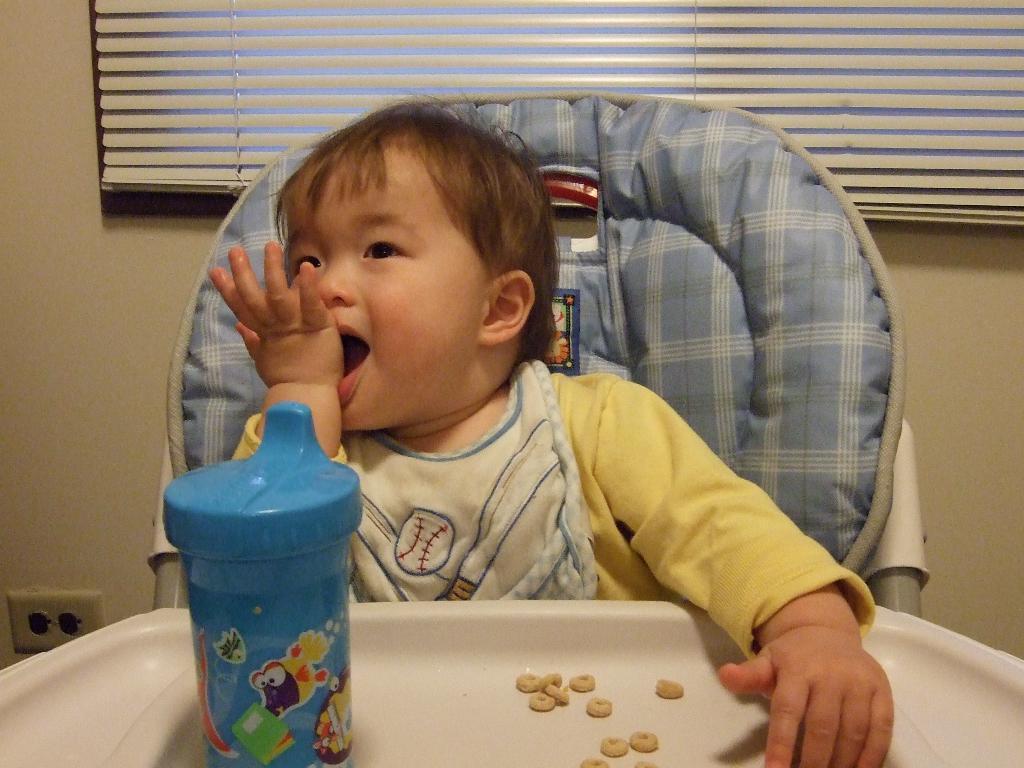Could you give a brief overview of what you see in this image? In this image there is a kid sitting in the table chair. In front of the kid there is a table on which there is a small bottle and some food beside it. In the background there is a curtain. 